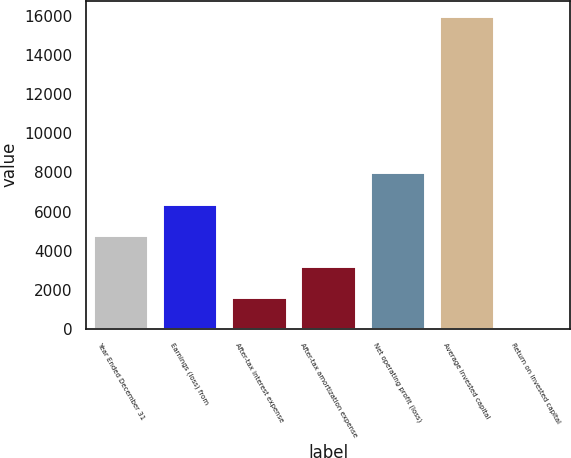Convert chart. <chart><loc_0><loc_0><loc_500><loc_500><bar_chart><fcel>Year Ended December 31<fcel>Earnings (loss) from<fcel>After-tax interest expense<fcel>After-tax amortization expense<fcel>Net operating profit (loss)<fcel>Average invested capital<fcel>Return on invested capital<nl><fcel>4808.32<fcel>6405.56<fcel>1613.84<fcel>3211.08<fcel>8002.8<fcel>15989<fcel>16.6<nl></chart> 